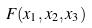<formula> <loc_0><loc_0><loc_500><loc_500>F ( x _ { 1 } , x _ { 2 } , x _ { 3 } )</formula> 